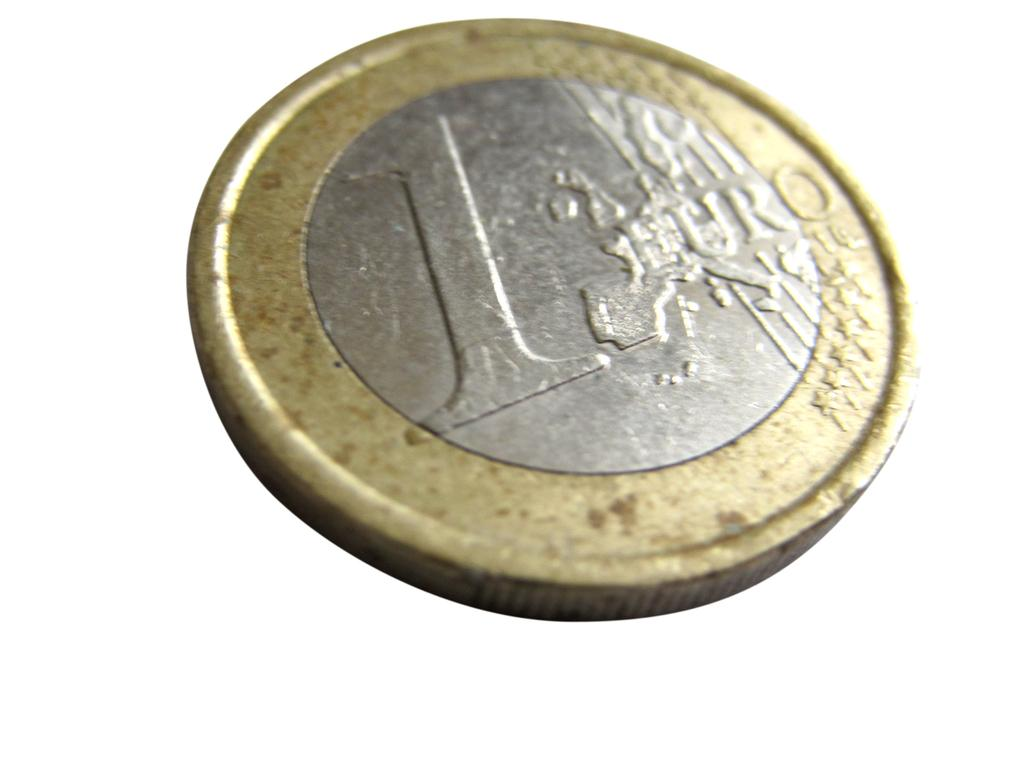Provide a one-sentence caption for the provided image. Circular metal coin with a gold rim around a silver center which contains a map of Europe and the words 1 EURO. 